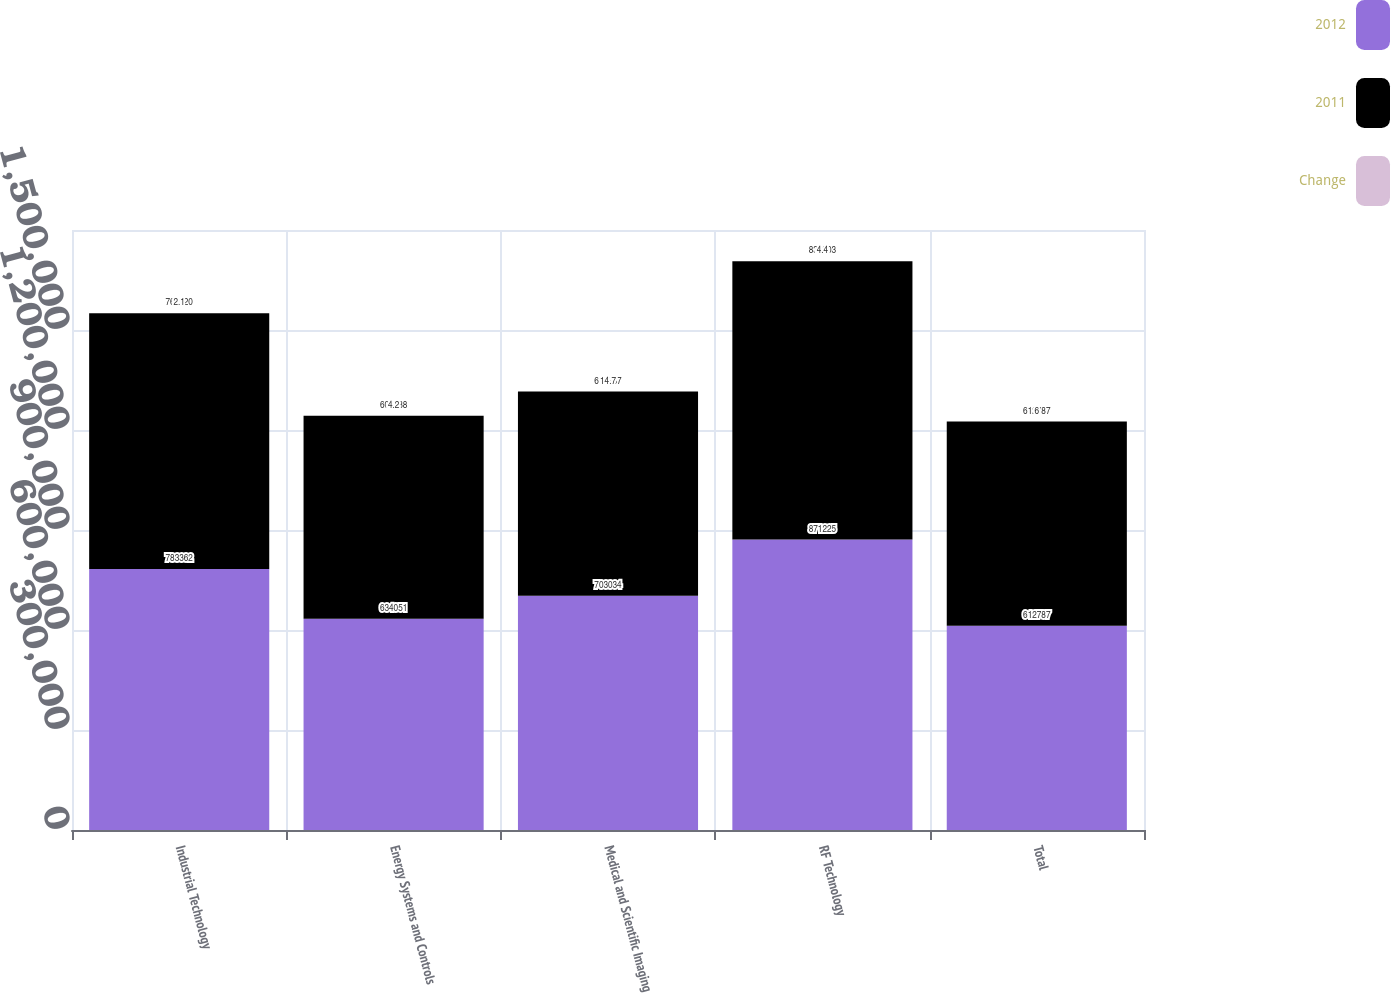<chart> <loc_0><loc_0><loc_500><loc_500><stacked_bar_chart><ecel><fcel>Industrial Technology<fcel>Energy Systems and Controls<fcel>Medical and Scientific Imaging<fcel>RF Technology<fcel>Total<nl><fcel>2012<fcel>783362<fcel>634051<fcel>703034<fcel>871225<fcel>612787<nl><fcel>2011<fcel>767020<fcel>608538<fcel>612787<fcel>834903<fcel>612787<nl><fcel>Change<fcel>2.1<fcel>4.2<fcel>14.7<fcel>4.4<fcel>6<nl></chart> 